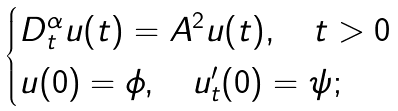<formula> <loc_0><loc_0><loc_500><loc_500>\begin{cases} D _ { t } ^ { \alpha } u ( t ) = A ^ { 2 } u ( t ) , \quad t > 0 \\ u ( 0 ) = \phi , \quad u _ { t } ^ { \prime } ( 0 ) = \psi ; \end{cases}</formula> 